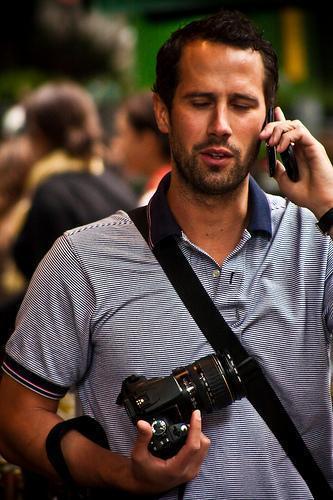How many cameras does the man have?
Give a very brief answer. 1. 